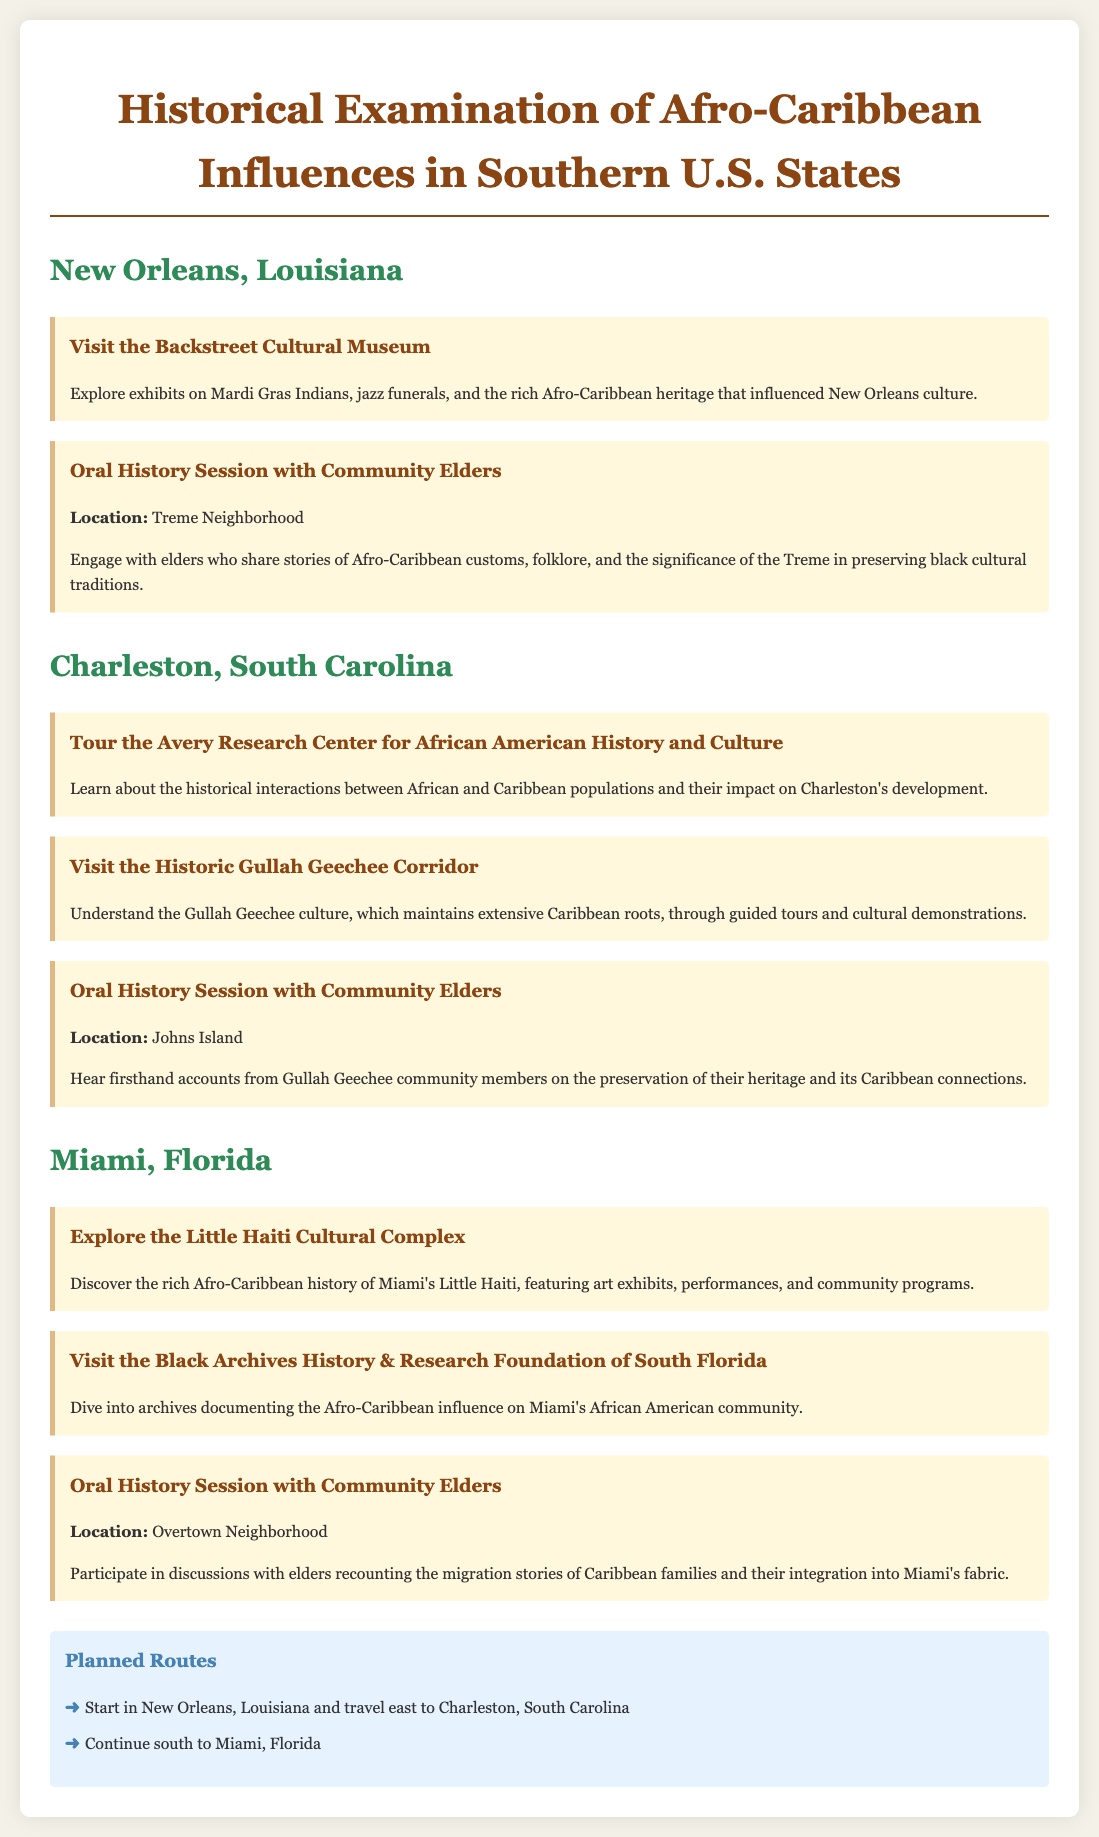What is the first city listed in the itinerary? The itinerary starts with New Orleans, Louisiana as the first city for exploration.
Answer: New Orleans, Louisiana What is the name of the cultural center visited in Miami? The itinerary includes a visit to the Little Haiti Cultural Complex, which is a key location in Miami.
Answer: Little Haiti Cultural Complex How many oral history sessions are planned in the itinerary? There are three oral history sessions mentioned, one in each of the cities specified.
Answer: Three Which historic culture is highlighted in Charleston, South Carolina? The itinerary emphasizes the Gullah Geechee culture, which has significant Afro-Caribbean influences.
Answer: Gullah Geechee What is one activity that takes place in the Treme Neighborhood? An oral history session with community elders is conducted in the Treme Neighborhood, focusing on cultural traditions.
Answer: Oral History Session What route does the itinerary suggest starting from New Orleans? The planned route begins in New Orleans, Louisiana and travels east to Charleston, South Carolina.
Answer: New Orleans to Charleston What type of exhibits can be found in the Backstreet Cultural Museum? The museum features exhibits relating to Mardi Gras Indians and jazz funerals, showcasing local cultural heritage.
Answer: Mardi Gras Indians, jazz funerals Where do the community elders share stories in Charleston? The oral history session with community elders takes place on Johns Island, which is part of Charleston's region.
Answer: Johns Island 